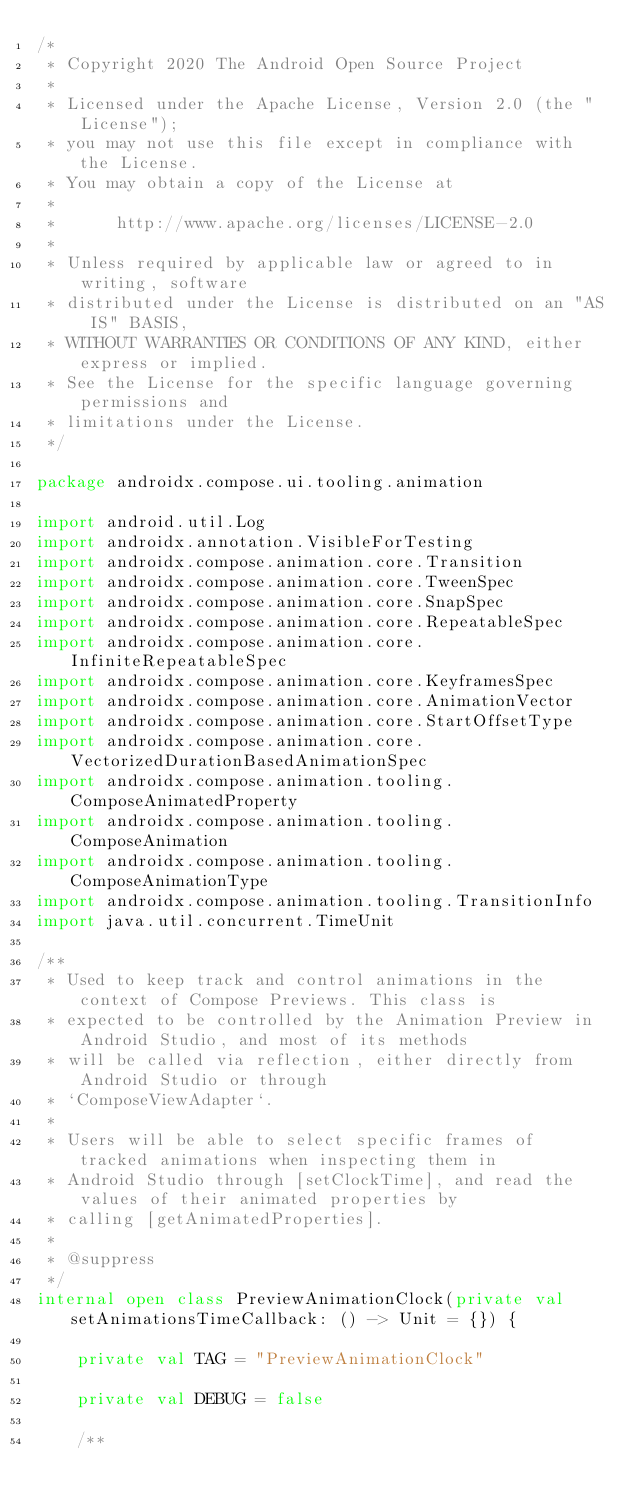<code> <loc_0><loc_0><loc_500><loc_500><_Kotlin_>/*
 * Copyright 2020 The Android Open Source Project
 *
 * Licensed under the Apache License, Version 2.0 (the "License");
 * you may not use this file except in compliance with the License.
 * You may obtain a copy of the License at
 *
 *      http://www.apache.org/licenses/LICENSE-2.0
 *
 * Unless required by applicable law or agreed to in writing, software
 * distributed under the License is distributed on an "AS IS" BASIS,
 * WITHOUT WARRANTIES OR CONDITIONS OF ANY KIND, either express or implied.
 * See the License for the specific language governing permissions and
 * limitations under the License.
 */

package androidx.compose.ui.tooling.animation

import android.util.Log
import androidx.annotation.VisibleForTesting
import androidx.compose.animation.core.Transition
import androidx.compose.animation.core.TweenSpec
import androidx.compose.animation.core.SnapSpec
import androidx.compose.animation.core.RepeatableSpec
import androidx.compose.animation.core.InfiniteRepeatableSpec
import androidx.compose.animation.core.KeyframesSpec
import androidx.compose.animation.core.AnimationVector
import androidx.compose.animation.core.StartOffsetType
import androidx.compose.animation.core.VectorizedDurationBasedAnimationSpec
import androidx.compose.animation.tooling.ComposeAnimatedProperty
import androidx.compose.animation.tooling.ComposeAnimation
import androidx.compose.animation.tooling.ComposeAnimationType
import androidx.compose.animation.tooling.TransitionInfo
import java.util.concurrent.TimeUnit

/**
 * Used to keep track and control animations in the context of Compose Previews. This class is
 * expected to be controlled by the Animation Preview in Android Studio, and most of its methods
 * will be called via reflection, either directly from Android Studio or through
 * `ComposeViewAdapter`.
 *
 * Users will be able to select specific frames of tracked animations when inspecting them in
 * Android Studio through [setClockTime], and read the values of their animated properties by
 * calling [getAnimatedProperties].
 *
 * @suppress
 */
internal open class PreviewAnimationClock(private val setAnimationsTimeCallback: () -> Unit = {}) {

    private val TAG = "PreviewAnimationClock"

    private val DEBUG = false

    /**</code> 